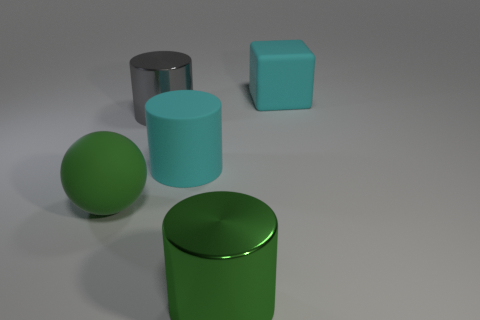Is the material of the big gray object the same as the big green cylinder?
Make the answer very short. Yes. How many other objects are the same material as the big cyan cube?
Ensure brevity in your answer.  2. How many large green things are both behind the green cylinder and in front of the big green matte sphere?
Keep it short and to the point. 0. What color is the large block?
Offer a terse response. Cyan. There is a large cyan thing that is the same shape as the gray metal object; what is its material?
Give a very brief answer. Rubber. Does the large cube have the same color as the large matte cylinder?
Your response must be concise. Yes. What is the shape of the large cyan matte thing right of the large cyan rubber thing that is in front of the big cube?
Provide a succinct answer. Cube. What shape is the large green object that is the same material as the block?
Make the answer very short. Sphere. How many other objects are the same shape as the large green metallic object?
Offer a very short reply. 2. Is the number of large matte spheres on the left side of the cube greater than the number of tiny yellow shiny cubes?
Provide a short and direct response. Yes. 